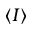Convert formula to latex. <formula><loc_0><loc_0><loc_500><loc_500>\langle I \rangle</formula> 